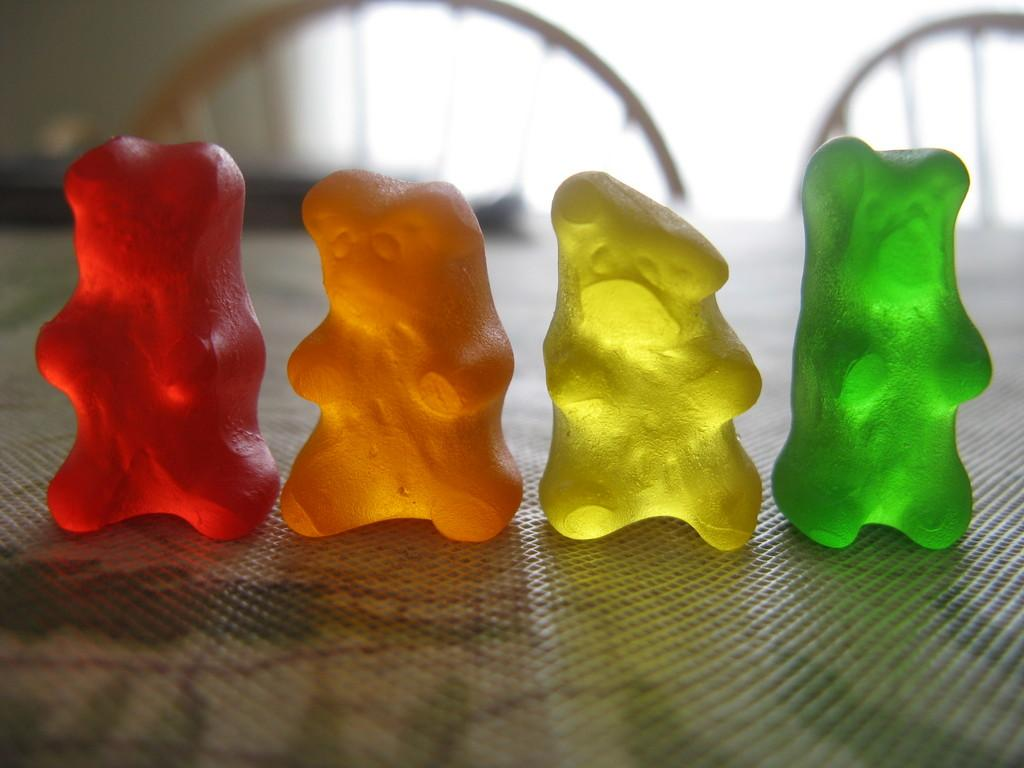What type of food is placed on the surface in the image? There are candies placed on a surface in the image. Can you describe the background of the image? There are chairs visible in the background of the image. Are there any fairies hiding among the candies in the image? There is no indication of fairies in the image; it only features candies placed on a surface and chairs in the background. 